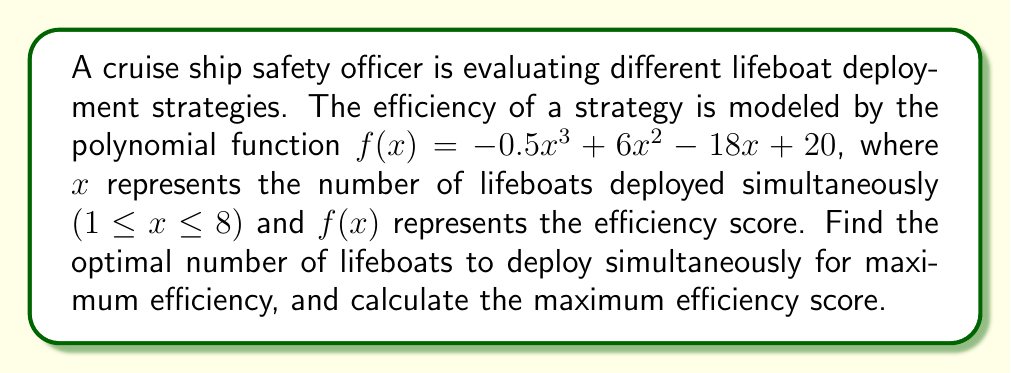Can you solve this math problem? To find the optimal number of lifeboats and the maximum efficiency score, we need to find the maximum value of the function $f(x) = -0.5x^3 + 6x^2 - 18x + 20$ within the given domain 1 ≤ x ≤ 8.

1) First, let's find the critical points by taking the derivative of $f(x)$ and setting it equal to zero:

   $f'(x) = -1.5x^2 + 12x - 18$
   $-1.5x^2 + 12x - 18 = 0$

2) Solve this quadratic equation:
   $-1.5(x^2 - 8x + 12) = 0$
   $-1.5(x - 6)(x - 2) = 0$
   $x = 6$ or $x = 2$

3) Since $x$ represents the number of lifeboats, it must be a whole number. Also, it must be within our domain of 1 ≤ x ≤ 8. So, we need to check the values of $f(x)$ at $x = 2$, $x = 6$, and the endpoints $x = 1$ and $x = 8$.

4) Calculate $f(x)$ for these values:
   $f(1) = -0.5(1)^3 + 6(1)^2 - 18(1) + 20 = 7.5$
   $f(2) = -0.5(2)^3 + 6(2)^2 - 18(2) + 20 = 16$
   $f(6) = -0.5(6)^3 + 6(6)^2 - 18(6) + 20 = 38$
   $f(8) = -0.5(8)^3 + 6(8)^2 - 18(8) + 20 = -28$

5) The maximum value occurs at $x = 6$, giving an efficiency score of 38.

Therefore, the optimal number of lifeboats to deploy simultaneously is 6, and the maximum efficiency score is 38.
Answer: The optimal number of lifeboats to deploy simultaneously is 6, with a maximum efficiency score of 38. 